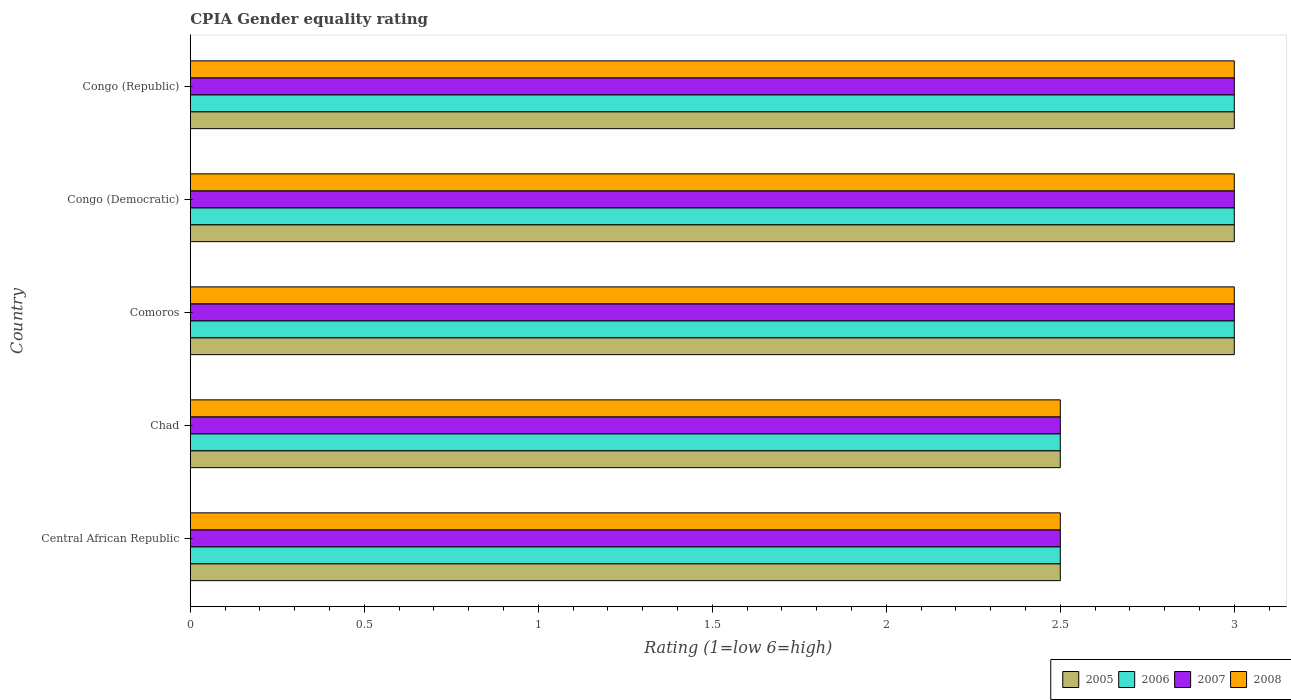How many groups of bars are there?
Your answer should be compact. 5. Are the number of bars per tick equal to the number of legend labels?
Your response must be concise. Yes. Are the number of bars on each tick of the Y-axis equal?
Your answer should be compact. Yes. How many bars are there on the 1st tick from the top?
Provide a short and direct response. 4. How many bars are there on the 1st tick from the bottom?
Offer a terse response. 4. What is the label of the 5th group of bars from the top?
Your response must be concise. Central African Republic. Across all countries, what is the maximum CPIA rating in 2006?
Ensure brevity in your answer.  3. Across all countries, what is the minimum CPIA rating in 2007?
Your answer should be very brief. 2.5. In which country was the CPIA rating in 2008 maximum?
Provide a short and direct response. Comoros. In which country was the CPIA rating in 2008 minimum?
Offer a terse response. Central African Republic. What is the difference between the CPIA rating in 2005 in Comoros and that in Congo (Democratic)?
Your response must be concise. 0. What is the average CPIA rating in 2005 per country?
Offer a very short reply. 2.8. What is the ratio of the CPIA rating in 2006 in Central African Republic to that in Congo (Democratic)?
Provide a short and direct response. 0.83. What is the difference between the highest and the second highest CPIA rating in 2005?
Provide a succinct answer. 0. In how many countries, is the CPIA rating in 2007 greater than the average CPIA rating in 2007 taken over all countries?
Make the answer very short. 3. Is it the case that in every country, the sum of the CPIA rating in 2007 and CPIA rating in 2008 is greater than the sum of CPIA rating in 2005 and CPIA rating in 2006?
Your answer should be compact. No. What does the 3rd bar from the bottom in Central African Republic represents?
Make the answer very short. 2007. How many bars are there?
Make the answer very short. 20. How many countries are there in the graph?
Provide a short and direct response. 5. What is the difference between two consecutive major ticks on the X-axis?
Provide a short and direct response. 0.5. Are the values on the major ticks of X-axis written in scientific E-notation?
Give a very brief answer. No. What is the title of the graph?
Ensure brevity in your answer.  CPIA Gender equality rating. Does "2001" appear as one of the legend labels in the graph?
Your answer should be compact. No. What is the Rating (1=low 6=high) in 2005 in Central African Republic?
Your response must be concise. 2.5. What is the Rating (1=low 6=high) of 2008 in Central African Republic?
Provide a short and direct response. 2.5. What is the Rating (1=low 6=high) of 2005 in Chad?
Make the answer very short. 2.5. What is the Rating (1=low 6=high) in 2006 in Chad?
Ensure brevity in your answer.  2.5. What is the Rating (1=low 6=high) in 2008 in Chad?
Give a very brief answer. 2.5. What is the Rating (1=low 6=high) of 2005 in Comoros?
Your answer should be very brief. 3. What is the Rating (1=low 6=high) in 2007 in Comoros?
Your answer should be compact. 3. What is the Rating (1=low 6=high) of 2005 in Congo (Democratic)?
Provide a succinct answer. 3. What is the Rating (1=low 6=high) of 2007 in Congo (Democratic)?
Ensure brevity in your answer.  3. What is the Rating (1=low 6=high) in 2008 in Congo (Republic)?
Offer a very short reply. 3. Across all countries, what is the maximum Rating (1=low 6=high) of 2005?
Your answer should be compact. 3. Across all countries, what is the maximum Rating (1=low 6=high) in 2007?
Provide a succinct answer. 3. Across all countries, what is the maximum Rating (1=low 6=high) in 2008?
Provide a short and direct response. 3. Across all countries, what is the minimum Rating (1=low 6=high) of 2007?
Your answer should be compact. 2.5. Across all countries, what is the minimum Rating (1=low 6=high) of 2008?
Your answer should be very brief. 2.5. What is the total Rating (1=low 6=high) of 2006 in the graph?
Offer a very short reply. 14. What is the total Rating (1=low 6=high) in 2007 in the graph?
Your answer should be compact. 14. What is the difference between the Rating (1=low 6=high) in 2006 in Central African Republic and that in Chad?
Your answer should be compact. 0. What is the difference between the Rating (1=low 6=high) of 2007 in Central African Republic and that in Chad?
Your answer should be compact. 0. What is the difference between the Rating (1=low 6=high) of 2006 in Central African Republic and that in Comoros?
Your answer should be very brief. -0.5. What is the difference between the Rating (1=low 6=high) of 2008 in Central African Republic and that in Comoros?
Make the answer very short. -0.5. What is the difference between the Rating (1=low 6=high) in 2007 in Central African Republic and that in Congo (Democratic)?
Offer a very short reply. -0.5. What is the difference between the Rating (1=low 6=high) of 2008 in Central African Republic and that in Congo (Democratic)?
Offer a terse response. -0.5. What is the difference between the Rating (1=low 6=high) in 2006 in Central African Republic and that in Congo (Republic)?
Your response must be concise. -0.5. What is the difference between the Rating (1=low 6=high) of 2007 in Central African Republic and that in Congo (Republic)?
Offer a very short reply. -0.5. What is the difference between the Rating (1=low 6=high) in 2005 in Chad and that in Comoros?
Provide a succinct answer. -0.5. What is the difference between the Rating (1=low 6=high) in 2006 in Chad and that in Comoros?
Give a very brief answer. -0.5. What is the difference between the Rating (1=low 6=high) of 2006 in Chad and that in Congo (Democratic)?
Give a very brief answer. -0.5. What is the difference between the Rating (1=low 6=high) of 2005 in Chad and that in Congo (Republic)?
Make the answer very short. -0.5. What is the difference between the Rating (1=low 6=high) in 2006 in Chad and that in Congo (Republic)?
Your answer should be very brief. -0.5. What is the difference between the Rating (1=low 6=high) in 2007 in Chad and that in Congo (Republic)?
Provide a short and direct response. -0.5. What is the difference between the Rating (1=low 6=high) of 2008 in Chad and that in Congo (Republic)?
Provide a succinct answer. -0.5. What is the difference between the Rating (1=low 6=high) in 2005 in Comoros and that in Congo (Republic)?
Make the answer very short. 0. What is the difference between the Rating (1=low 6=high) of 2008 in Comoros and that in Congo (Republic)?
Provide a short and direct response. 0. What is the difference between the Rating (1=low 6=high) in 2006 in Congo (Democratic) and that in Congo (Republic)?
Offer a terse response. 0. What is the difference between the Rating (1=low 6=high) in 2008 in Congo (Democratic) and that in Congo (Republic)?
Ensure brevity in your answer.  0. What is the difference between the Rating (1=low 6=high) of 2005 in Central African Republic and the Rating (1=low 6=high) of 2006 in Chad?
Your answer should be compact. 0. What is the difference between the Rating (1=low 6=high) in 2005 in Central African Republic and the Rating (1=low 6=high) in 2007 in Chad?
Give a very brief answer. 0. What is the difference between the Rating (1=low 6=high) of 2005 in Central African Republic and the Rating (1=low 6=high) of 2008 in Chad?
Provide a succinct answer. 0. What is the difference between the Rating (1=low 6=high) of 2006 in Central African Republic and the Rating (1=low 6=high) of 2008 in Chad?
Make the answer very short. 0. What is the difference between the Rating (1=low 6=high) of 2007 in Central African Republic and the Rating (1=low 6=high) of 2008 in Chad?
Your answer should be very brief. 0. What is the difference between the Rating (1=low 6=high) of 2005 in Central African Republic and the Rating (1=low 6=high) of 2006 in Comoros?
Offer a very short reply. -0.5. What is the difference between the Rating (1=low 6=high) of 2005 in Central African Republic and the Rating (1=low 6=high) of 2007 in Comoros?
Provide a succinct answer. -0.5. What is the difference between the Rating (1=low 6=high) in 2005 in Central African Republic and the Rating (1=low 6=high) in 2008 in Comoros?
Make the answer very short. -0.5. What is the difference between the Rating (1=low 6=high) of 2007 in Central African Republic and the Rating (1=low 6=high) of 2008 in Comoros?
Your answer should be compact. -0.5. What is the difference between the Rating (1=low 6=high) in 2005 in Central African Republic and the Rating (1=low 6=high) in 2006 in Congo (Democratic)?
Keep it short and to the point. -0.5. What is the difference between the Rating (1=low 6=high) in 2005 in Central African Republic and the Rating (1=low 6=high) in 2007 in Congo (Democratic)?
Make the answer very short. -0.5. What is the difference between the Rating (1=low 6=high) of 2005 in Central African Republic and the Rating (1=low 6=high) of 2008 in Congo (Democratic)?
Provide a short and direct response. -0.5. What is the difference between the Rating (1=low 6=high) of 2006 in Central African Republic and the Rating (1=low 6=high) of 2007 in Congo (Democratic)?
Provide a short and direct response. -0.5. What is the difference between the Rating (1=low 6=high) of 2006 in Central African Republic and the Rating (1=low 6=high) of 2008 in Congo (Democratic)?
Make the answer very short. -0.5. What is the difference between the Rating (1=low 6=high) in 2007 in Central African Republic and the Rating (1=low 6=high) in 2008 in Congo (Democratic)?
Ensure brevity in your answer.  -0.5. What is the difference between the Rating (1=low 6=high) of 2005 in Central African Republic and the Rating (1=low 6=high) of 2006 in Congo (Republic)?
Provide a succinct answer. -0.5. What is the difference between the Rating (1=low 6=high) in 2005 in Central African Republic and the Rating (1=low 6=high) in 2008 in Congo (Republic)?
Keep it short and to the point. -0.5. What is the difference between the Rating (1=low 6=high) of 2006 in Central African Republic and the Rating (1=low 6=high) of 2007 in Congo (Republic)?
Provide a succinct answer. -0.5. What is the difference between the Rating (1=low 6=high) in 2006 in Central African Republic and the Rating (1=low 6=high) in 2008 in Congo (Republic)?
Your answer should be very brief. -0.5. What is the difference between the Rating (1=low 6=high) in 2007 in Central African Republic and the Rating (1=low 6=high) in 2008 in Congo (Republic)?
Make the answer very short. -0.5. What is the difference between the Rating (1=low 6=high) in 2005 in Chad and the Rating (1=low 6=high) in 2008 in Comoros?
Keep it short and to the point. -0.5. What is the difference between the Rating (1=low 6=high) of 2006 in Chad and the Rating (1=low 6=high) of 2008 in Comoros?
Ensure brevity in your answer.  -0.5. What is the difference between the Rating (1=low 6=high) in 2007 in Chad and the Rating (1=low 6=high) in 2008 in Comoros?
Provide a succinct answer. -0.5. What is the difference between the Rating (1=low 6=high) of 2005 in Chad and the Rating (1=low 6=high) of 2007 in Congo (Democratic)?
Ensure brevity in your answer.  -0.5. What is the difference between the Rating (1=low 6=high) of 2005 in Chad and the Rating (1=low 6=high) of 2008 in Congo (Democratic)?
Your answer should be very brief. -0.5. What is the difference between the Rating (1=low 6=high) in 2006 in Chad and the Rating (1=low 6=high) in 2007 in Congo (Democratic)?
Your answer should be compact. -0.5. What is the difference between the Rating (1=low 6=high) in 2005 in Chad and the Rating (1=low 6=high) in 2006 in Congo (Republic)?
Give a very brief answer. -0.5. What is the difference between the Rating (1=low 6=high) of 2005 in Chad and the Rating (1=low 6=high) of 2007 in Congo (Republic)?
Provide a succinct answer. -0.5. What is the difference between the Rating (1=low 6=high) of 2005 in Chad and the Rating (1=low 6=high) of 2008 in Congo (Republic)?
Your answer should be compact. -0.5. What is the difference between the Rating (1=low 6=high) of 2006 in Chad and the Rating (1=low 6=high) of 2007 in Congo (Republic)?
Give a very brief answer. -0.5. What is the difference between the Rating (1=low 6=high) in 2005 in Comoros and the Rating (1=low 6=high) in 2007 in Congo (Democratic)?
Ensure brevity in your answer.  0. What is the difference between the Rating (1=low 6=high) of 2005 in Comoros and the Rating (1=low 6=high) of 2008 in Congo (Democratic)?
Your response must be concise. 0. What is the difference between the Rating (1=low 6=high) of 2006 in Comoros and the Rating (1=low 6=high) of 2007 in Congo (Democratic)?
Provide a short and direct response. 0. What is the difference between the Rating (1=low 6=high) of 2006 in Comoros and the Rating (1=low 6=high) of 2008 in Congo (Democratic)?
Ensure brevity in your answer.  0. What is the difference between the Rating (1=low 6=high) of 2005 in Comoros and the Rating (1=low 6=high) of 2006 in Congo (Republic)?
Provide a succinct answer. 0. What is the difference between the Rating (1=low 6=high) of 2005 in Comoros and the Rating (1=low 6=high) of 2007 in Congo (Republic)?
Keep it short and to the point. 0. What is the difference between the Rating (1=low 6=high) of 2005 in Comoros and the Rating (1=low 6=high) of 2008 in Congo (Republic)?
Provide a succinct answer. 0. What is the difference between the Rating (1=low 6=high) of 2007 in Comoros and the Rating (1=low 6=high) of 2008 in Congo (Republic)?
Offer a very short reply. 0. What is the difference between the Rating (1=low 6=high) in 2005 in Congo (Democratic) and the Rating (1=low 6=high) in 2006 in Congo (Republic)?
Offer a terse response. 0. What is the difference between the Rating (1=low 6=high) in 2005 in Congo (Democratic) and the Rating (1=low 6=high) in 2007 in Congo (Republic)?
Provide a short and direct response. 0. What is the difference between the Rating (1=low 6=high) in 2005 in Congo (Democratic) and the Rating (1=low 6=high) in 2008 in Congo (Republic)?
Make the answer very short. 0. What is the difference between the Rating (1=low 6=high) of 2006 in Congo (Democratic) and the Rating (1=low 6=high) of 2008 in Congo (Republic)?
Your answer should be very brief. 0. What is the difference between the Rating (1=low 6=high) in 2007 in Congo (Democratic) and the Rating (1=low 6=high) in 2008 in Congo (Republic)?
Keep it short and to the point. 0. What is the average Rating (1=low 6=high) in 2005 per country?
Ensure brevity in your answer.  2.8. What is the average Rating (1=low 6=high) in 2006 per country?
Provide a short and direct response. 2.8. What is the difference between the Rating (1=low 6=high) in 2005 and Rating (1=low 6=high) in 2007 in Central African Republic?
Provide a succinct answer. 0. What is the difference between the Rating (1=low 6=high) in 2006 and Rating (1=low 6=high) in 2007 in Central African Republic?
Give a very brief answer. 0. What is the difference between the Rating (1=low 6=high) in 2005 and Rating (1=low 6=high) in 2007 in Chad?
Ensure brevity in your answer.  0. What is the difference between the Rating (1=low 6=high) in 2007 and Rating (1=low 6=high) in 2008 in Chad?
Your answer should be compact. 0. What is the difference between the Rating (1=low 6=high) of 2006 and Rating (1=low 6=high) of 2007 in Comoros?
Offer a very short reply. 0. What is the difference between the Rating (1=low 6=high) in 2007 and Rating (1=low 6=high) in 2008 in Comoros?
Provide a short and direct response. 0. What is the difference between the Rating (1=low 6=high) in 2006 and Rating (1=low 6=high) in 2008 in Congo (Democratic)?
Your answer should be compact. 0. What is the difference between the Rating (1=low 6=high) in 2005 and Rating (1=low 6=high) in 2006 in Congo (Republic)?
Keep it short and to the point. 0. What is the difference between the Rating (1=low 6=high) of 2005 and Rating (1=low 6=high) of 2008 in Congo (Republic)?
Your answer should be compact. 0. What is the difference between the Rating (1=low 6=high) in 2006 and Rating (1=low 6=high) in 2007 in Congo (Republic)?
Ensure brevity in your answer.  0. What is the difference between the Rating (1=low 6=high) in 2007 and Rating (1=low 6=high) in 2008 in Congo (Republic)?
Ensure brevity in your answer.  0. What is the ratio of the Rating (1=low 6=high) in 2006 in Central African Republic to that in Chad?
Give a very brief answer. 1. What is the ratio of the Rating (1=low 6=high) in 2007 in Central African Republic to that in Chad?
Make the answer very short. 1. What is the ratio of the Rating (1=low 6=high) in 2008 in Central African Republic to that in Chad?
Your answer should be compact. 1. What is the ratio of the Rating (1=low 6=high) of 2007 in Central African Republic to that in Comoros?
Provide a succinct answer. 0.83. What is the ratio of the Rating (1=low 6=high) in 2005 in Central African Republic to that in Congo (Democratic)?
Your answer should be very brief. 0.83. What is the ratio of the Rating (1=low 6=high) of 2007 in Central African Republic to that in Congo (Democratic)?
Keep it short and to the point. 0.83. What is the ratio of the Rating (1=low 6=high) in 2008 in Central African Republic to that in Congo (Democratic)?
Offer a terse response. 0.83. What is the ratio of the Rating (1=low 6=high) of 2005 in Central African Republic to that in Congo (Republic)?
Offer a very short reply. 0.83. What is the ratio of the Rating (1=low 6=high) in 2005 in Chad to that in Comoros?
Ensure brevity in your answer.  0.83. What is the ratio of the Rating (1=low 6=high) of 2007 in Chad to that in Comoros?
Your answer should be very brief. 0.83. What is the ratio of the Rating (1=low 6=high) in 2008 in Chad to that in Comoros?
Your answer should be very brief. 0.83. What is the ratio of the Rating (1=low 6=high) in 2006 in Chad to that in Congo (Democratic)?
Your answer should be compact. 0.83. What is the ratio of the Rating (1=low 6=high) in 2007 in Chad to that in Congo (Democratic)?
Your answer should be very brief. 0.83. What is the ratio of the Rating (1=low 6=high) in 2007 in Chad to that in Congo (Republic)?
Offer a very short reply. 0.83. What is the ratio of the Rating (1=low 6=high) in 2008 in Chad to that in Congo (Republic)?
Keep it short and to the point. 0.83. What is the ratio of the Rating (1=low 6=high) in 2008 in Comoros to that in Congo (Republic)?
Make the answer very short. 1. What is the ratio of the Rating (1=low 6=high) in 2005 in Congo (Democratic) to that in Congo (Republic)?
Give a very brief answer. 1. What is the ratio of the Rating (1=low 6=high) in 2006 in Congo (Democratic) to that in Congo (Republic)?
Provide a succinct answer. 1. What is the difference between the highest and the second highest Rating (1=low 6=high) in 2007?
Keep it short and to the point. 0. What is the difference between the highest and the second highest Rating (1=low 6=high) in 2008?
Provide a short and direct response. 0. What is the difference between the highest and the lowest Rating (1=low 6=high) of 2008?
Keep it short and to the point. 0.5. 